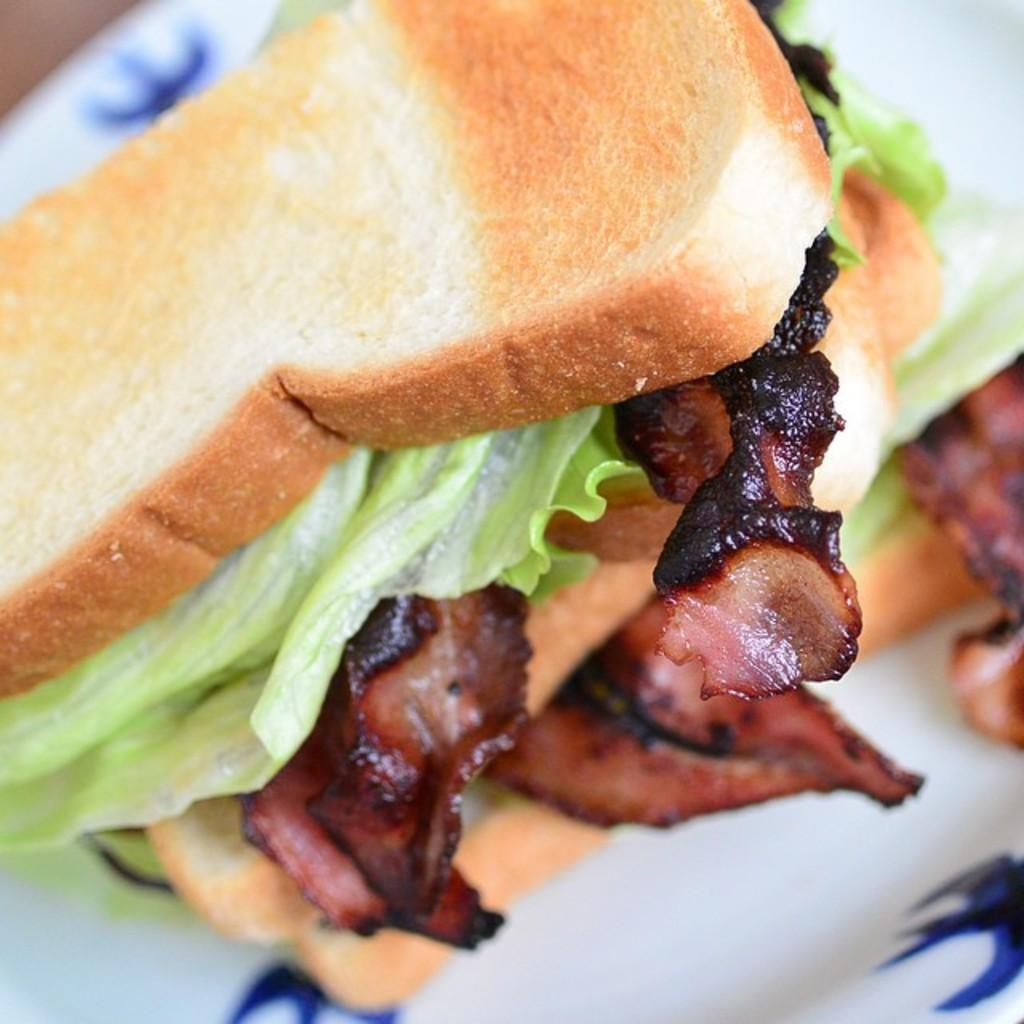What is the color of the plate in the image? The plate in the image is white. What can be found on the plate? There are different types of food on the plate. Can you describe the quality of the image? The image is slightly blurry. Where is the boot placed in the image? There is no boot present in the image. What type of rake is being used to harvest the food on the plate? There is no rake present in the image, and the food is not being harvested. 